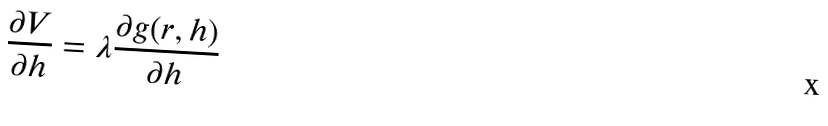<formula> <loc_0><loc_0><loc_500><loc_500>\frac { \partial V } { \partial h } = \lambda \frac { \partial g ( r , h ) } { \partial h }</formula> 